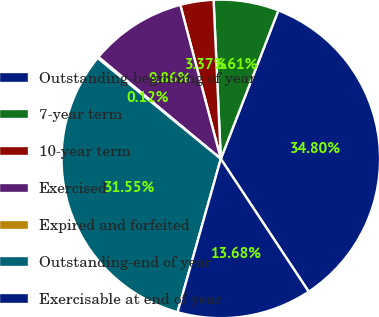Convert chart. <chart><loc_0><loc_0><loc_500><loc_500><pie_chart><fcel>Outstanding-beginning of year<fcel>7-year term<fcel>10-year term<fcel>Exercised<fcel>Expired and forfeited<fcel>Outstanding-end of year<fcel>Exercisable at end of year<nl><fcel>34.8%<fcel>6.61%<fcel>3.37%<fcel>9.86%<fcel>0.12%<fcel>31.55%<fcel>13.68%<nl></chart> 